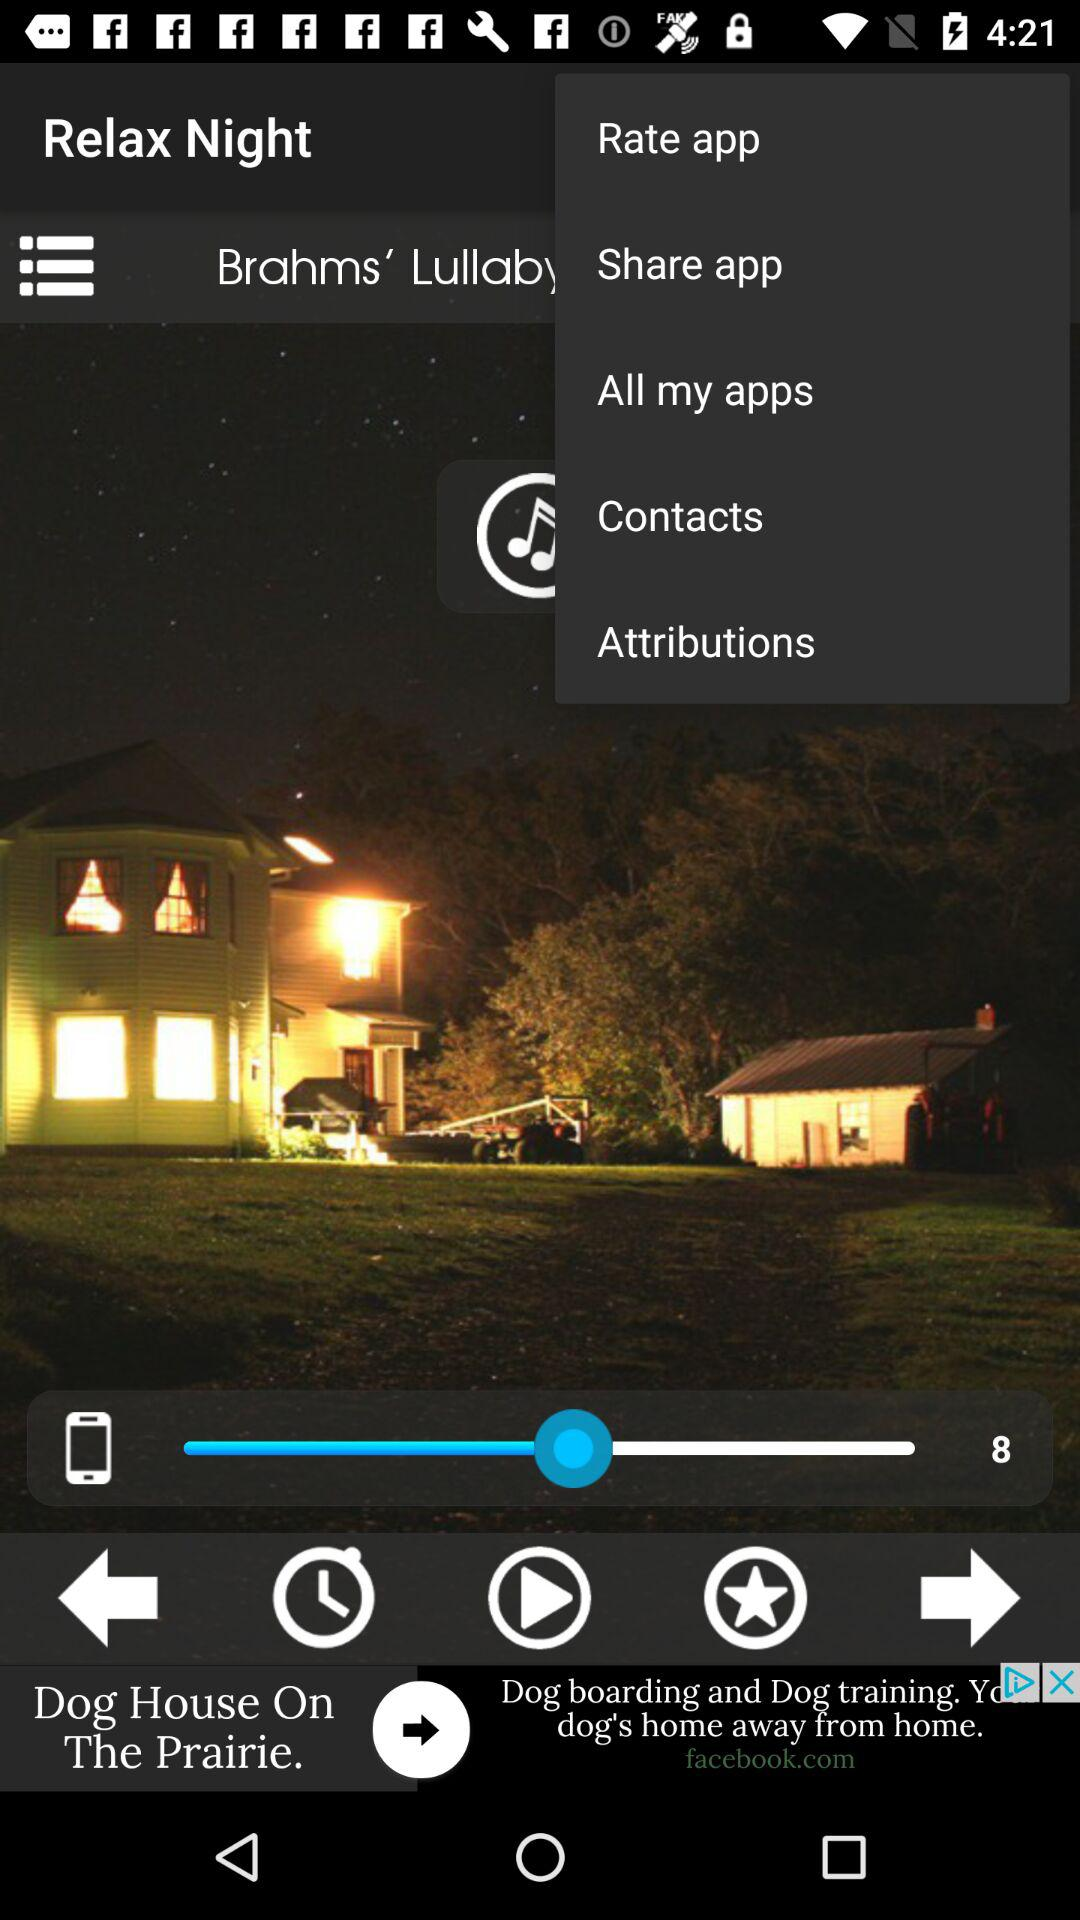What is the volume level? The volume level is 8. 